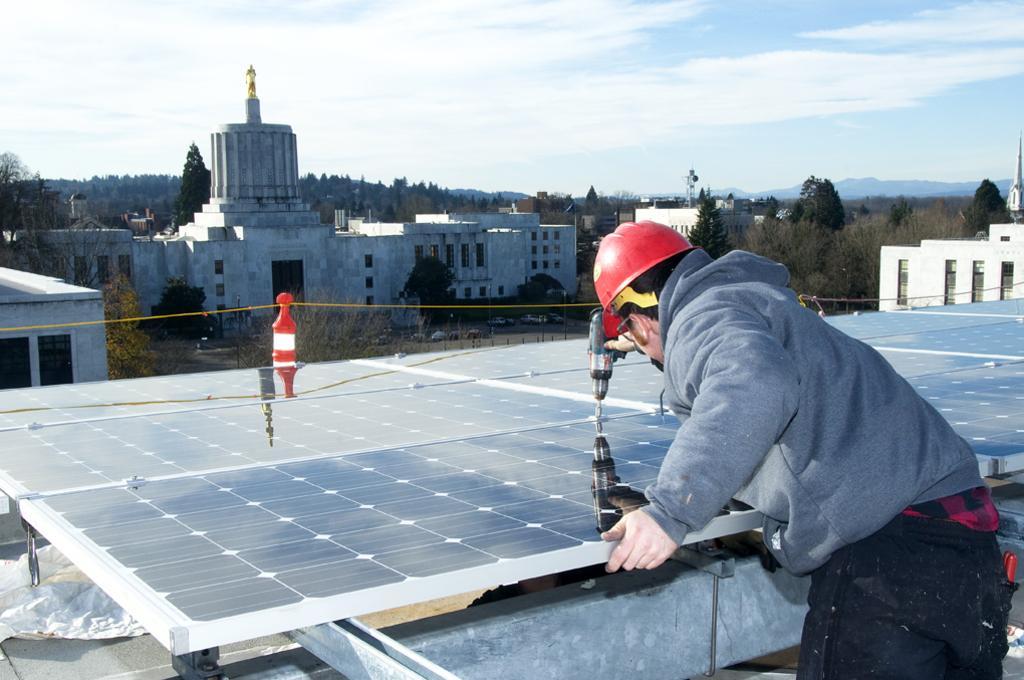Please provide a concise description of this image. In the center of the image we can see a table, rope. In the background of the image we can see the buildings, trees, statue, tower, hills, fence, vehicles and ground. In the bottom right corner we can see a man is wearing a jacket, helmet and holding a drilling machine. At the top of the image we can see the clouds in the sky. 